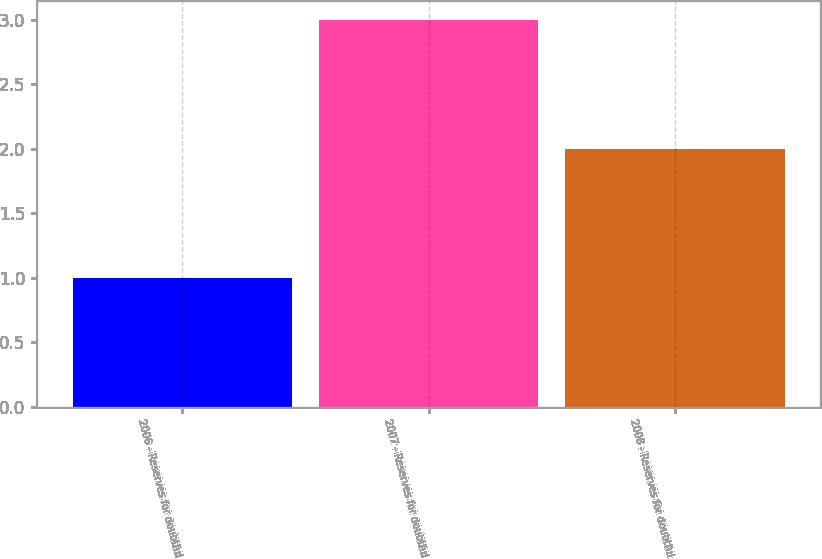<chart> <loc_0><loc_0><loc_500><loc_500><bar_chart><fcel>2006 - Reserves for doubtful<fcel>2007 - Reserves for doubtful<fcel>2008 - Reserves for doubtful<nl><fcel>1<fcel>3<fcel>2<nl></chart> 